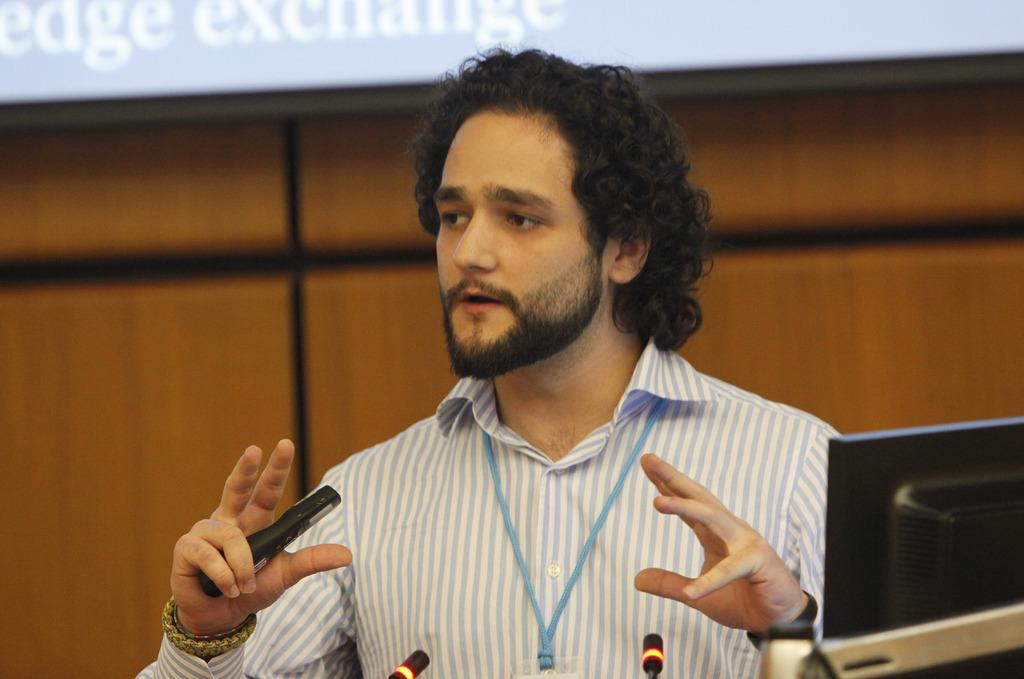Who is present in the image? There is a man in the image. What is the man doing in the image? The man is standing at a computer. What can be seen in the background of the image? There is a wall in the background of the image. How many chickens are visible in the image? There are no chickens present in the image. What type of van is parked next to the man in the image? There is no van present in the image. 